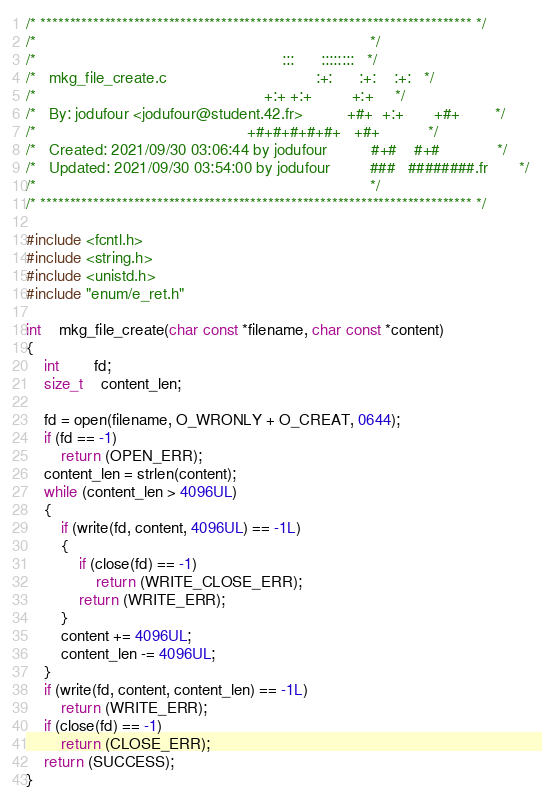<code> <loc_0><loc_0><loc_500><loc_500><_C_>/* ************************************************************************** */
/*                                                                            */
/*                                                        :::      ::::::::   */
/*   mkg_file_create.c                                  :+:      :+:    :+:   */
/*                                                    +:+ +:+         +:+     */
/*   By: jodufour <jodufour@student.42.fr>          +#+  +:+       +#+        */
/*                                                +#+#+#+#+#+   +#+           */
/*   Created: 2021/09/30 03:06:44 by jodufour          #+#    #+#             */
/*   Updated: 2021/09/30 03:54:00 by jodufour         ###   ########.fr       */
/*                                                                            */
/* ************************************************************************** */

#include <fcntl.h>
#include <string.h>
#include <unistd.h>
#include "enum/e_ret.h"

int	mkg_file_create(char const *filename, char const *content)
{
	int		fd;
	size_t	content_len;

	fd = open(filename, O_WRONLY + O_CREAT, 0644);
	if (fd == -1)
		return (OPEN_ERR);
	content_len = strlen(content);
	while (content_len > 4096UL)
	{
		if (write(fd, content, 4096UL) == -1L)
		{
			if (close(fd) == -1)
				return (WRITE_CLOSE_ERR);
			return (WRITE_ERR);
		}
		content += 4096UL;
		content_len -= 4096UL;
	}
	if (write(fd, content, content_len) == -1L)
		return (WRITE_ERR);
	if (close(fd) == -1)
		return (CLOSE_ERR);
	return (SUCCESS);
}
</code> 